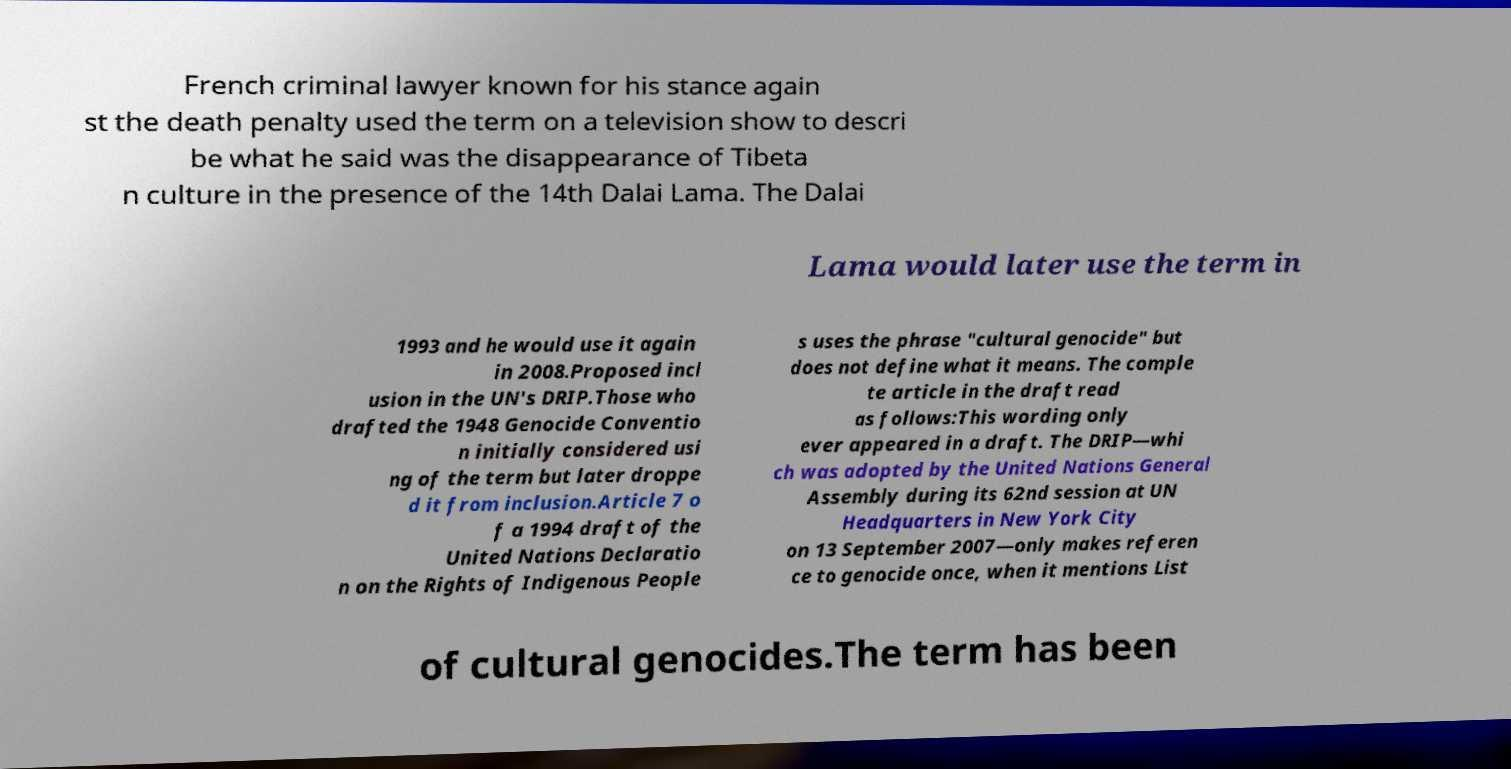Could you extract and type out the text from this image? French criminal lawyer known for his stance again st the death penalty used the term on a television show to descri be what he said was the disappearance of Tibeta n culture in the presence of the 14th Dalai Lama. The Dalai Lama would later use the term in 1993 and he would use it again in 2008.Proposed incl usion in the UN's DRIP.Those who drafted the 1948 Genocide Conventio n initially considered usi ng of the term but later droppe d it from inclusion.Article 7 o f a 1994 draft of the United Nations Declaratio n on the Rights of Indigenous People s uses the phrase "cultural genocide" but does not define what it means. The comple te article in the draft read as follows:This wording only ever appeared in a draft. The DRIP—whi ch was adopted by the United Nations General Assembly during its 62nd session at UN Headquarters in New York City on 13 September 2007—only makes referen ce to genocide once, when it mentions List of cultural genocides.The term has been 